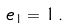<formula> <loc_0><loc_0><loc_500><loc_500>e _ { 1 } = 1 \, .</formula> 